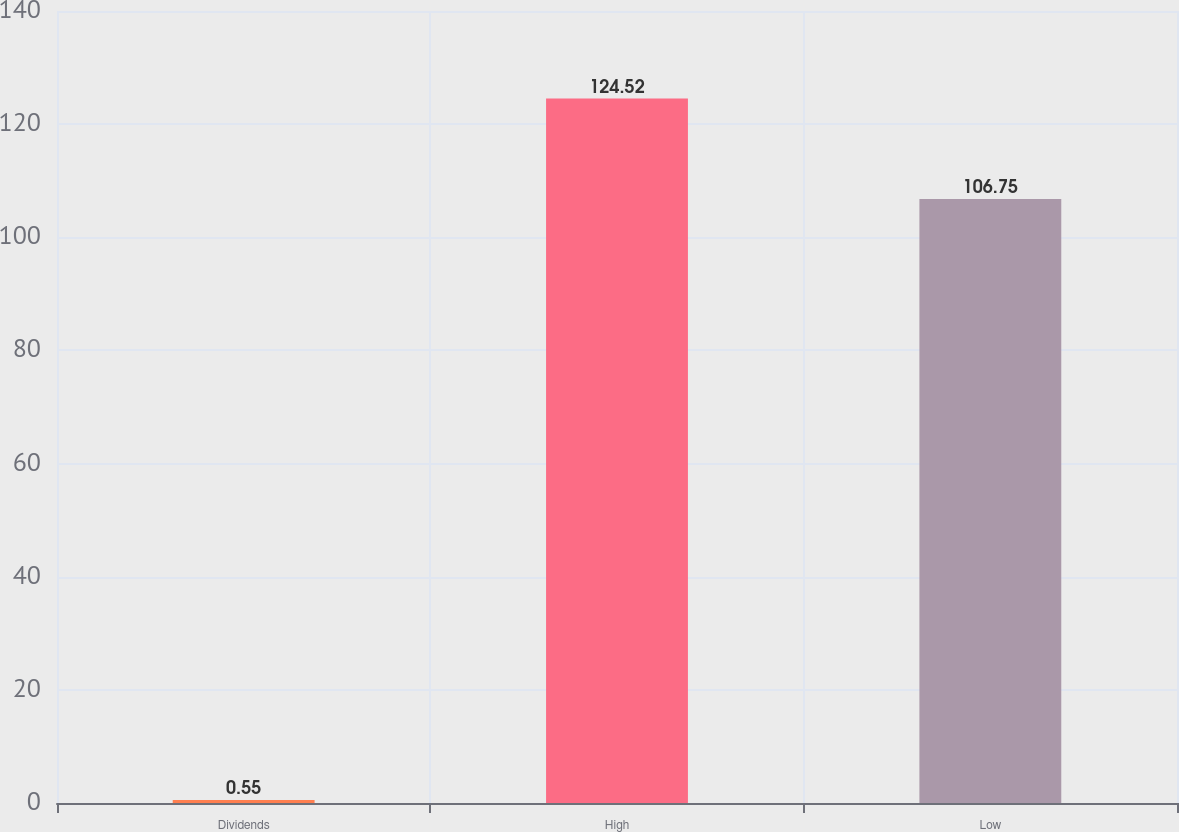Convert chart to OTSL. <chart><loc_0><loc_0><loc_500><loc_500><bar_chart><fcel>Dividends<fcel>High<fcel>Low<nl><fcel>0.55<fcel>124.52<fcel>106.75<nl></chart> 